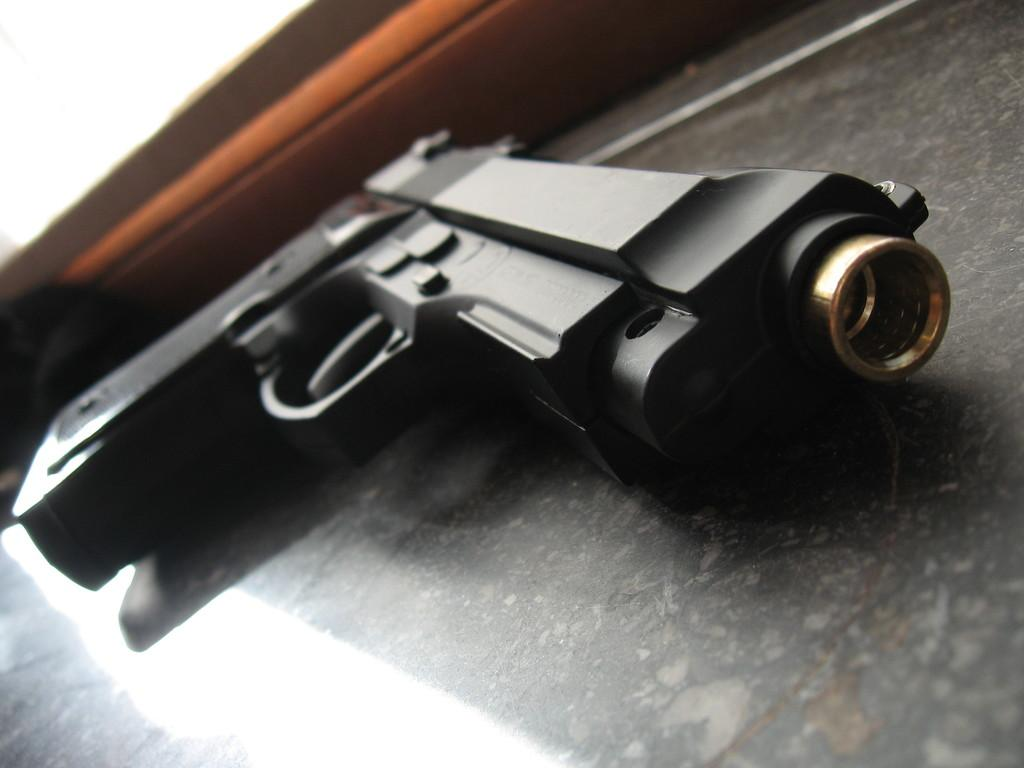What object is the main focus of the image? There is a gun in the image. What can be seen in the background of the image? There is a wall in the background of the image. What type of rule does the woman in the image enforce? There is no woman present in the image, so it is not possible to answer that question. 